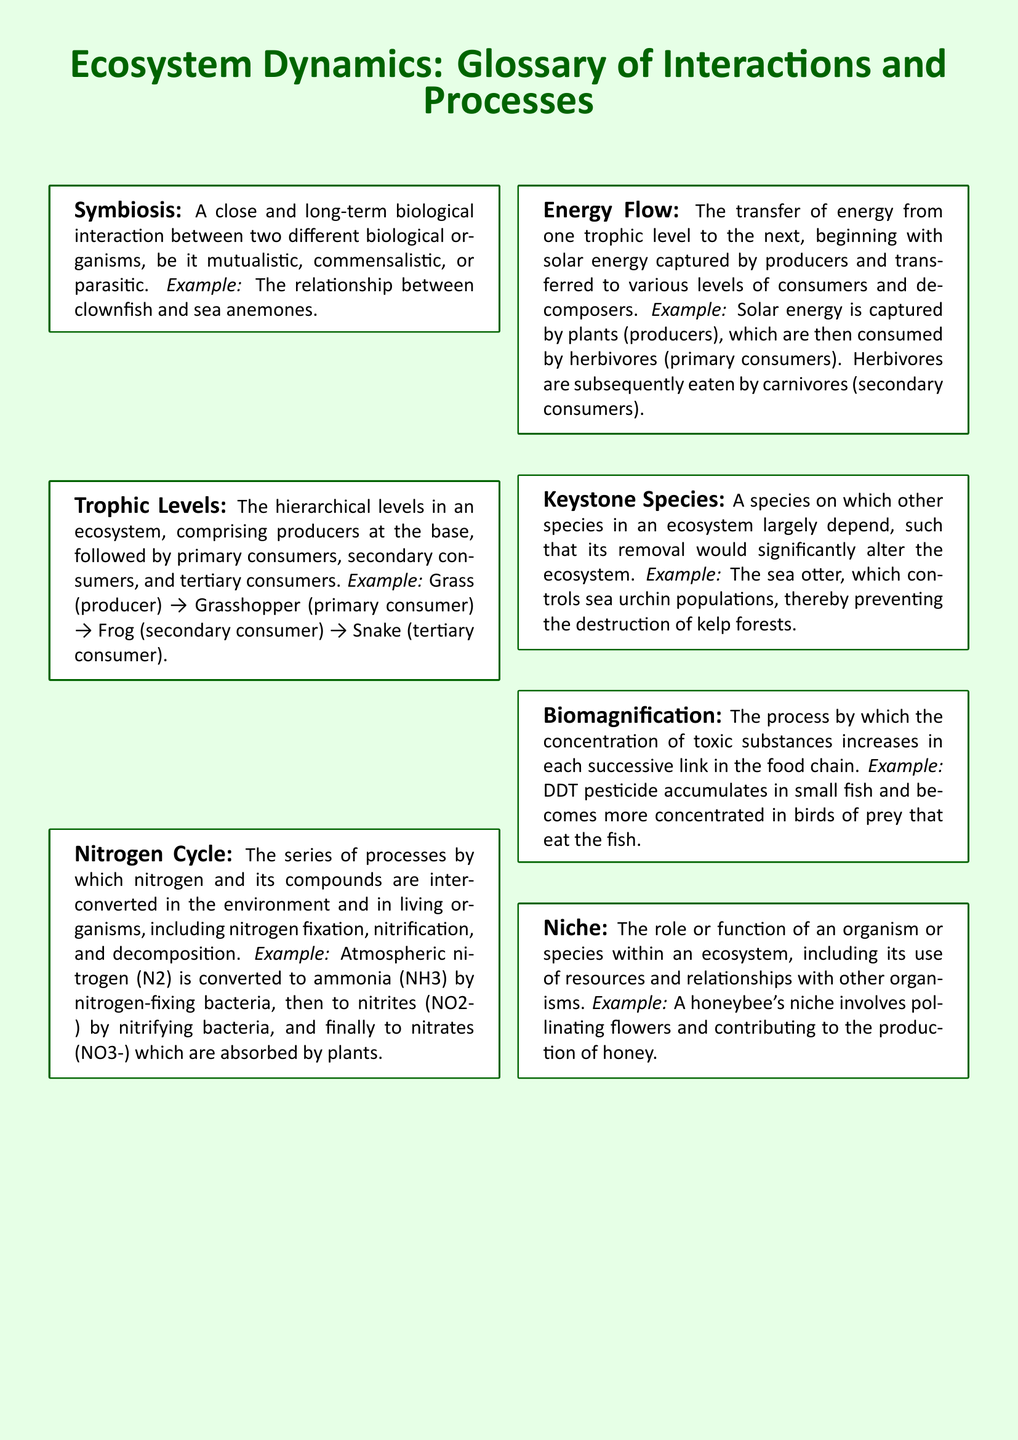What is the definition of symbiosis? The definition of symbiosis is provided in the glossary as a close and long-term biological interaction between two different biological organisms, be it mutualistic, commensalistic, or parasitic.
Answer: A close and long-term biological interaction between two different biological organisms What is an example of a keystone species? The glossary provides an example of a keystone species, specifically noting the sea otter, which plays a crucial role in its ecosystem.
Answer: Sea otter How many trophic levels are mentioned in the document? The document outlines a hierarchy consisting of producers, primary consumers, secondary consumers, and tertiary consumers, which amounts to four trophic levels.
Answer: Four What does biomagnification refer to in the glossary? The glossary states that biomagnification refers to the process by which the concentration of toxic substances increases in each successive link in the food chain.
Answer: The process by which the concentration of toxic substances increases in each successive link in the food chain Which process starts the nitrogen cycle according to the document? The glossary indicates that nitrogen fixation is the first process mentioned in the nitrogen cycle.
Answer: Nitrogen fixation What energy captures the initial stage of energy flow in ecosystems? The document specifies that solar energy is the energy captured by producers at the initial stage of energy flow in ecosystems.
Answer: Solar energy What role does a honeybee play in its ecosystem? The glossary describes that a honeybee's niche involves pollinating flowers and contributing to the production of honey.
Answer: Pollinating flowers and contributing to the production of honey What is the color scheme used for the glossary background? The document features a light green background color for the glossary.
Answer: Light green 